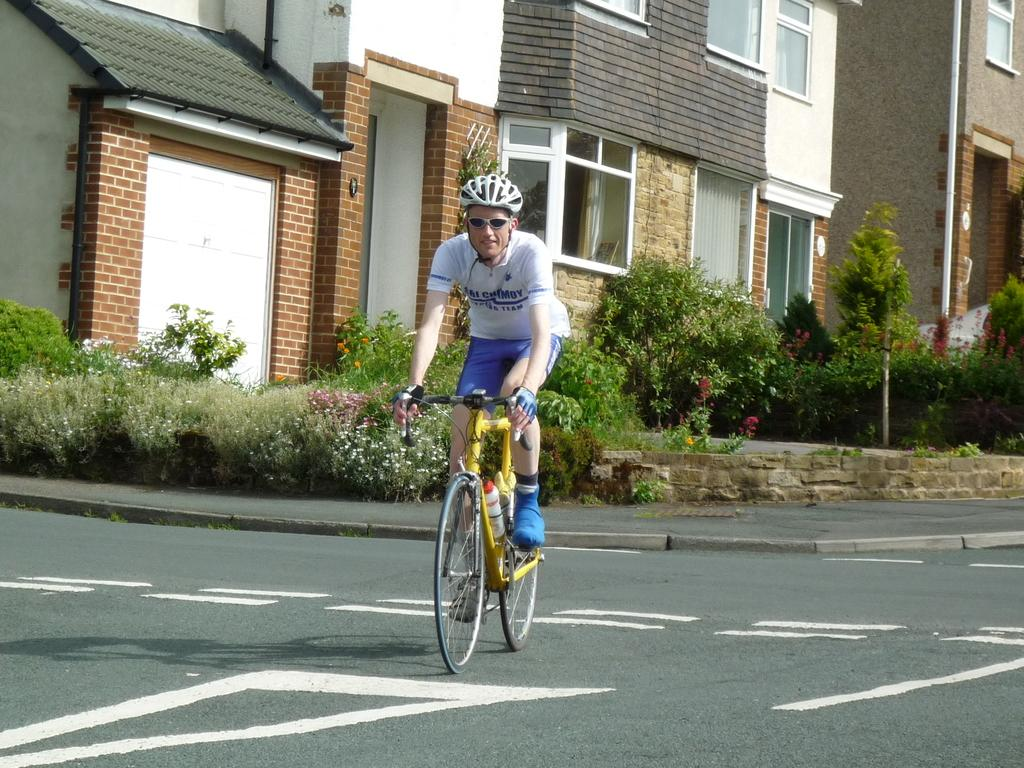Who is the main subject in the image? There is a man in the image. What is the man wearing on his head? The man is wearing a helmet. What activity is the man engaged in? The man is riding a bicycle. What type of vegetation can be seen in the image? There are plants visible in the image. What type of structures are present in the image? There are buildings in the image. What type of pin can be seen holding the man's pants in the image? There is no pin visible in the image, and the man's pants are not being held up by a pin. 